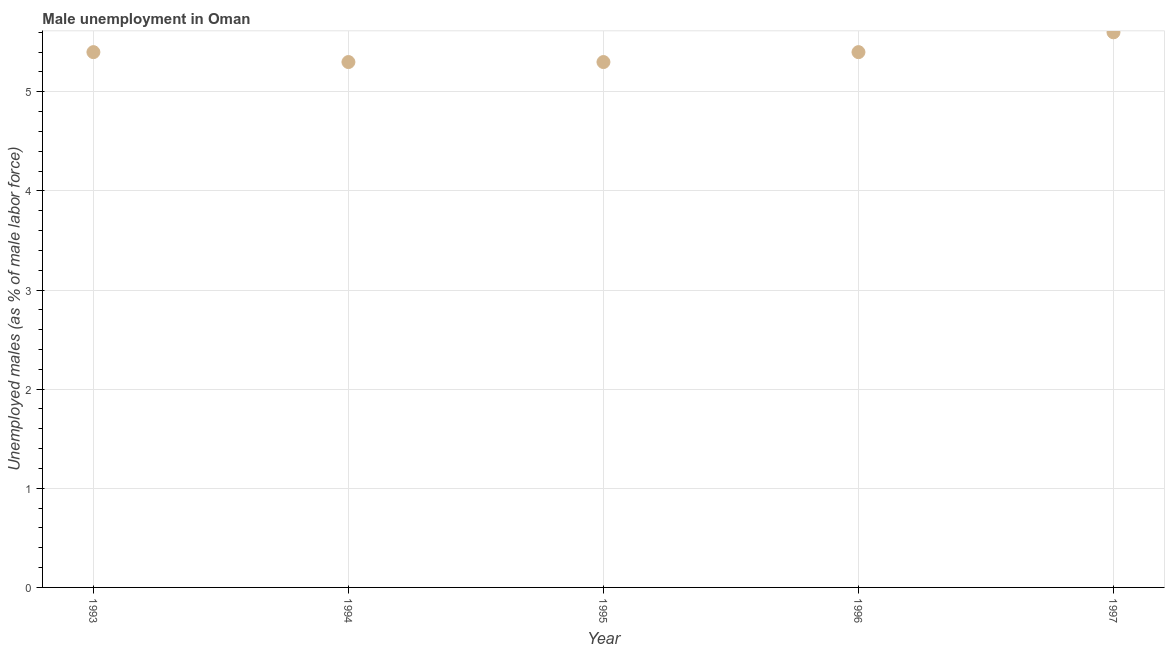What is the unemployed males population in 1993?
Ensure brevity in your answer.  5.4. Across all years, what is the maximum unemployed males population?
Offer a terse response. 5.6. Across all years, what is the minimum unemployed males population?
Your answer should be very brief. 5.3. In which year was the unemployed males population maximum?
Make the answer very short. 1997. In which year was the unemployed males population minimum?
Your answer should be compact. 1994. What is the sum of the unemployed males population?
Your answer should be very brief. 27. What is the average unemployed males population per year?
Provide a short and direct response. 5.4. What is the median unemployed males population?
Your answer should be compact. 5.4. In how many years, is the unemployed males population greater than 1.2 %?
Your answer should be compact. 5. What is the ratio of the unemployed males population in 1995 to that in 1997?
Your answer should be very brief. 0.95. What is the difference between the highest and the second highest unemployed males population?
Keep it short and to the point. 0.2. Is the sum of the unemployed males population in 1995 and 1997 greater than the maximum unemployed males population across all years?
Give a very brief answer. Yes. What is the difference between the highest and the lowest unemployed males population?
Your answer should be very brief. 0.3. In how many years, is the unemployed males population greater than the average unemployed males population taken over all years?
Offer a terse response. 1. How many years are there in the graph?
Provide a short and direct response. 5. Does the graph contain grids?
Your answer should be compact. Yes. What is the title of the graph?
Keep it short and to the point. Male unemployment in Oman. What is the label or title of the X-axis?
Your answer should be very brief. Year. What is the label or title of the Y-axis?
Your answer should be very brief. Unemployed males (as % of male labor force). What is the Unemployed males (as % of male labor force) in 1993?
Give a very brief answer. 5.4. What is the Unemployed males (as % of male labor force) in 1994?
Offer a terse response. 5.3. What is the Unemployed males (as % of male labor force) in 1995?
Provide a succinct answer. 5.3. What is the Unemployed males (as % of male labor force) in 1996?
Give a very brief answer. 5.4. What is the Unemployed males (as % of male labor force) in 1997?
Provide a succinct answer. 5.6. What is the difference between the Unemployed males (as % of male labor force) in 1993 and 1996?
Your response must be concise. 0. What is the difference between the Unemployed males (as % of male labor force) in 1993 and 1997?
Ensure brevity in your answer.  -0.2. What is the difference between the Unemployed males (as % of male labor force) in 1994 and 1997?
Offer a very short reply. -0.3. What is the difference between the Unemployed males (as % of male labor force) in 1995 and 1996?
Ensure brevity in your answer.  -0.1. What is the difference between the Unemployed males (as % of male labor force) in 1995 and 1997?
Keep it short and to the point. -0.3. What is the difference between the Unemployed males (as % of male labor force) in 1996 and 1997?
Provide a succinct answer. -0.2. What is the ratio of the Unemployed males (as % of male labor force) in 1993 to that in 1994?
Ensure brevity in your answer.  1.02. What is the ratio of the Unemployed males (as % of male labor force) in 1993 to that in 1996?
Offer a terse response. 1. What is the ratio of the Unemployed males (as % of male labor force) in 1993 to that in 1997?
Your response must be concise. 0.96. What is the ratio of the Unemployed males (as % of male labor force) in 1994 to that in 1995?
Provide a short and direct response. 1. What is the ratio of the Unemployed males (as % of male labor force) in 1994 to that in 1997?
Give a very brief answer. 0.95. What is the ratio of the Unemployed males (as % of male labor force) in 1995 to that in 1997?
Provide a short and direct response. 0.95. 